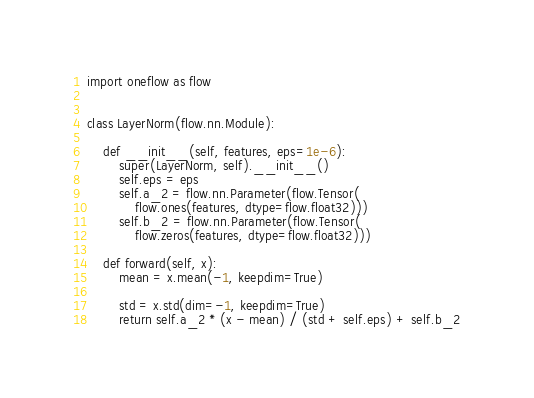<code> <loc_0><loc_0><loc_500><loc_500><_Python_>import oneflow as flow


class LayerNorm(flow.nn.Module):

    def __init__(self, features, eps=1e-6):
        super(LayerNorm, self).__init__()
        self.eps = eps
        self.a_2 = flow.nn.Parameter(flow.Tensor(
            flow.ones(features, dtype=flow.float32)))
        self.b_2 = flow.nn.Parameter(flow.Tensor(
            flow.zeros(features, dtype=flow.float32)))

    def forward(self, x):
        mean = x.mean(-1, keepdim=True)

        std = x.std(dim=-1, keepdim=True)
        return self.a_2 * (x - mean) / (std + self.eps) + self.b_2
</code> 